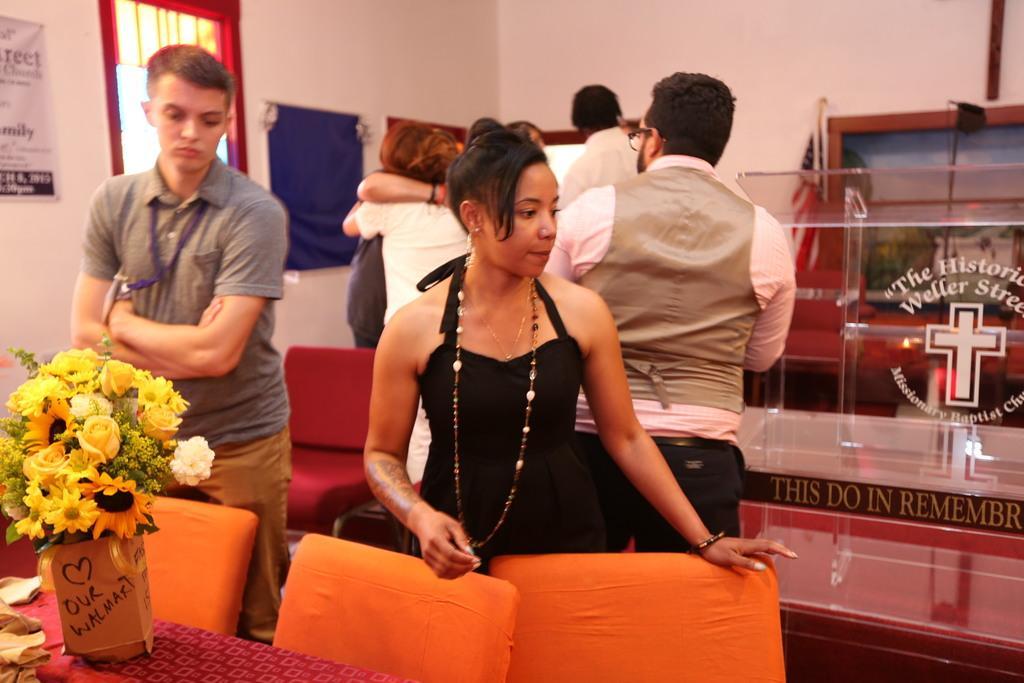Describe this image in one or two sentences. This picture is clicked inside the room. In the foreground there is a flower vase placed on the top of the table and we can see an orange color chairs and there is a woman wearing black color dress and standing on the ground and we can see the group of people standing on the ground. On a right there is a glass object placed on the ground. In the background we can see the chairs, wallboard, window and a poster hanging on the wall and there is a text written on the poster. 